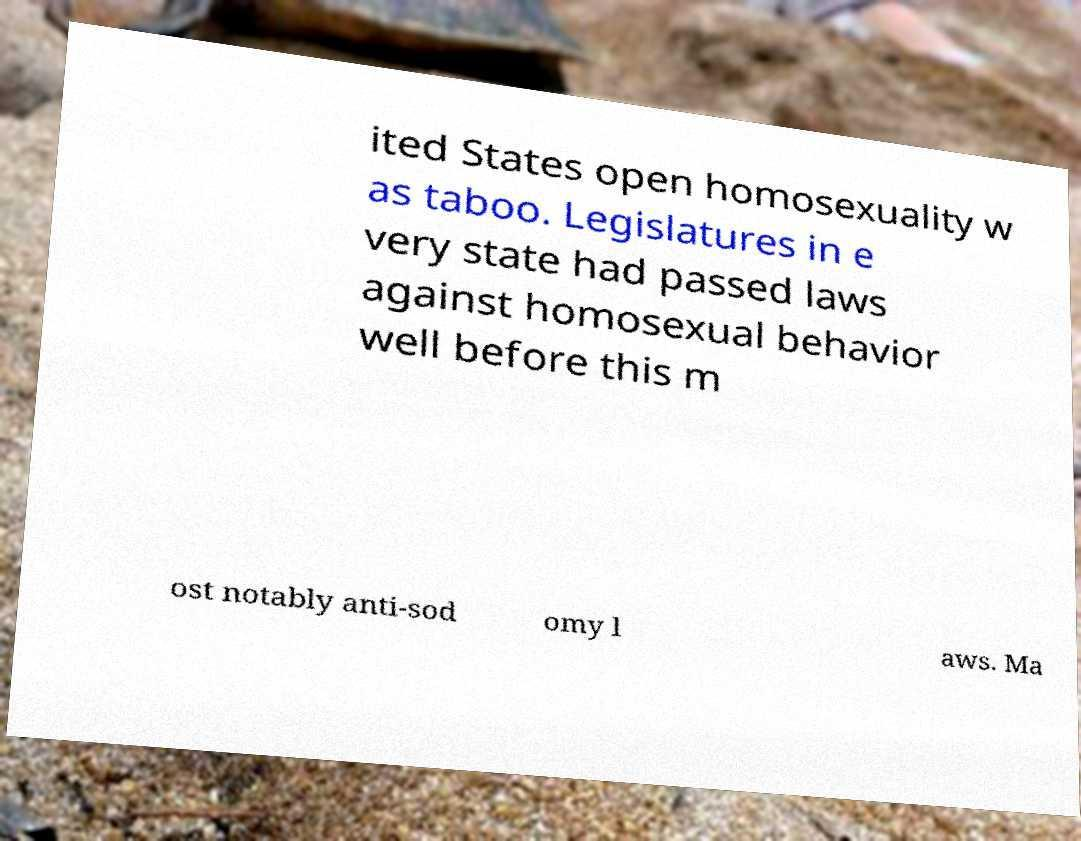Could you extract and type out the text from this image? ited States open homosexuality w as taboo. Legislatures in e very state had passed laws against homosexual behavior well before this m ost notably anti-sod omy l aws. Ma 